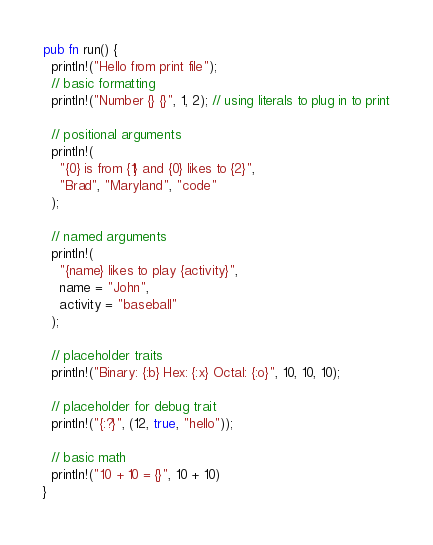Convert code to text. <code><loc_0><loc_0><loc_500><loc_500><_Rust_>pub fn run() {
  println!("Hello from print file");
  // basic formatting
  println!("Number {} {}", 1, 2); // using literals to plug in to print

  // positional arguments
  println!(
    "{0} is from {1} and {0} likes to {2}",
    "Brad", "Maryland", "code"
  );

  // named arguments
  println!(
    "{name} likes to play {activity}",
    name = "John",
    activity = "baseball"
  );

  // placeholder traits
  println!("Binary: {:b} Hex: {:x} Octal: {:o}", 10, 10, 10);

  // placeholder for debug trait
  println!("{:?}", (12, true, "hello"));

  // basic math
  println!("10 + 10 = {}", 10 + 10)
}
</code> 